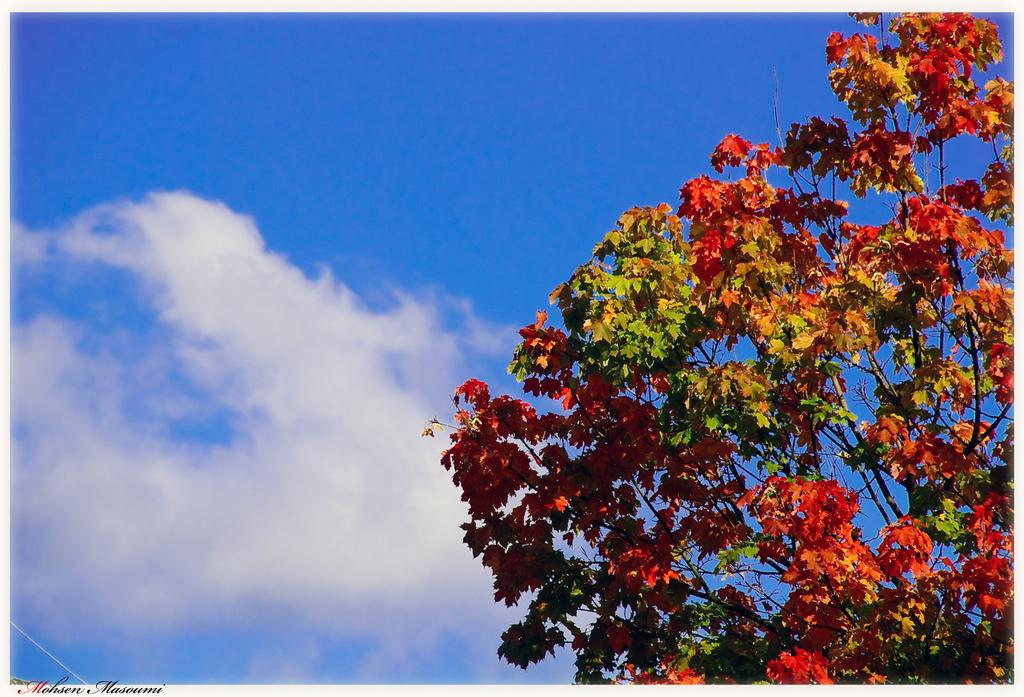What is the main subject of the picture? The main subject of the picture is a tree. What colors are the leaves on the tree? The tree has orange and green leaves. What can be seen in the background of the tree? There is a sky visible in the background of the tree. How many spiders are crawling on the tree in the image? There are no spiders visible on the tree in the image. What type of bath can be seen in the image? There is no bath present in the image; it features a tree with orange and green leaves. 